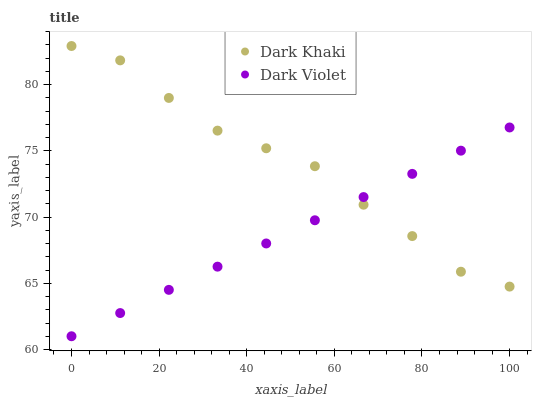Does Dark Violet have the minimum area under the curve?
Answer yes or no. Yes. Does Dark Khaki have the maximum area under the curve?
Answer yes or no. Yes. Does Dark Violet have the maximum area under the curve?
Answer yes or no. No. Is Dark Violet the smoothest?
Answer yes or no. Yes. Is Dark Khaki the roughest?
Answer yes or no. Yes. Is Dark Violet the roughest?
Answer yes or no. No. Does Dark Violet have the lowest value?
Answer yes or no. Yes. Does Dark Khaki have the highest value?
Answer yes or no. Yes. Does Dark Violet have the highest value?
Answer yes or no. No. Does Dark Khaki intersect Dark Violet?
Answer yes or no. Yes. Is Dark Khaki less than Dark Violet?
Answer yes or no. No. Is Dark Khaki greater than Dark Violet?
Answer yes or no. No. 